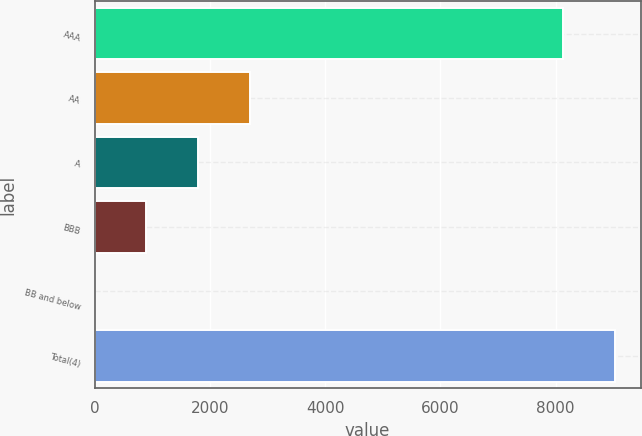<chart> <loc_0><loc_0><loc_500><loc_500><bar_chart><fcel>AAA<fcel>AA<fcel>A<fcel>BBB<fcel>BB and below<fcel>Total(4)<nl><fcel>8125<fcel>2693.22<fcel>1795.96<fcel>898.7<fcel>1.44<fcel>9022.26<nl></chart> 